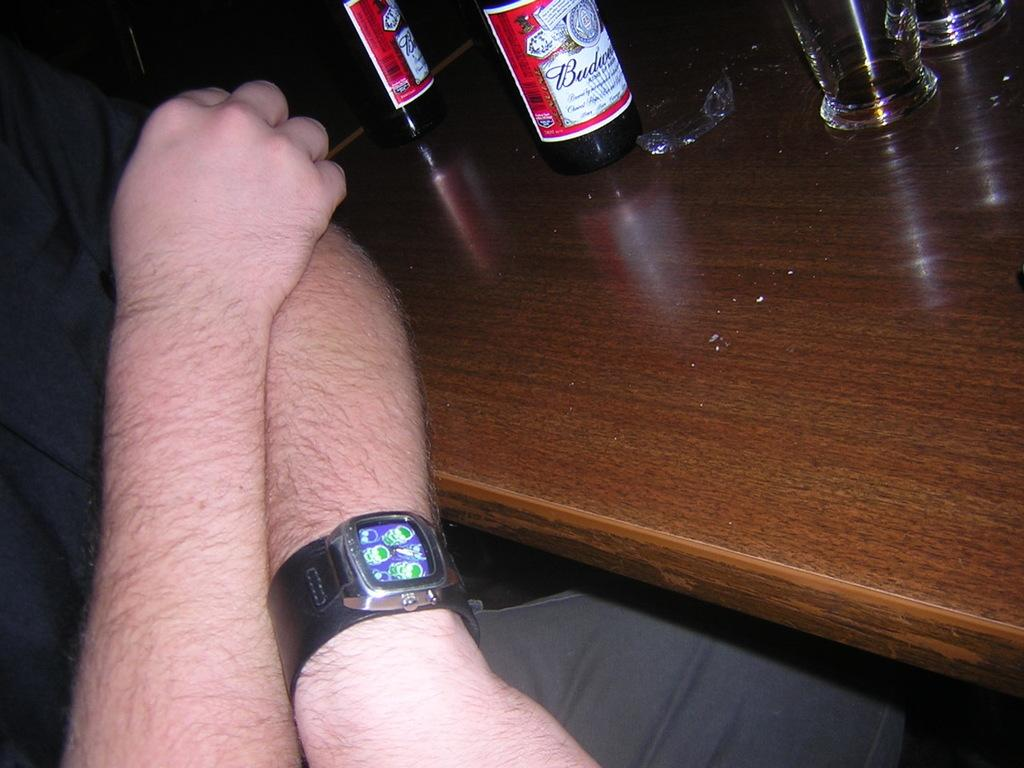<image>
Relay a brief, clear account of the picture shown. A Budweiser label can be seen on a bottle on the table. 